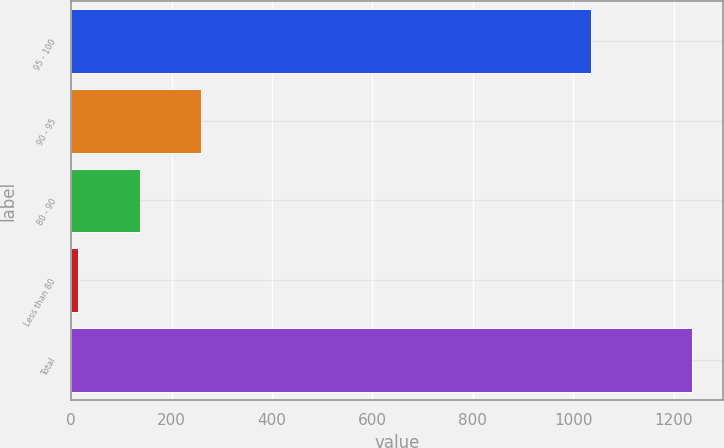Convert chart to OTSL. <chart><loc_0><loc_0><loc_500><loc_500><bar_chart><fcel>95 - 100<fcel>90 - 95<fcel>80 - 90<fcel>Less than 80<fcel>Total<nl><fcel>1035<fcel>258.4<fcel>136.2<fcel>14<fcel>1236<nl></chart> 